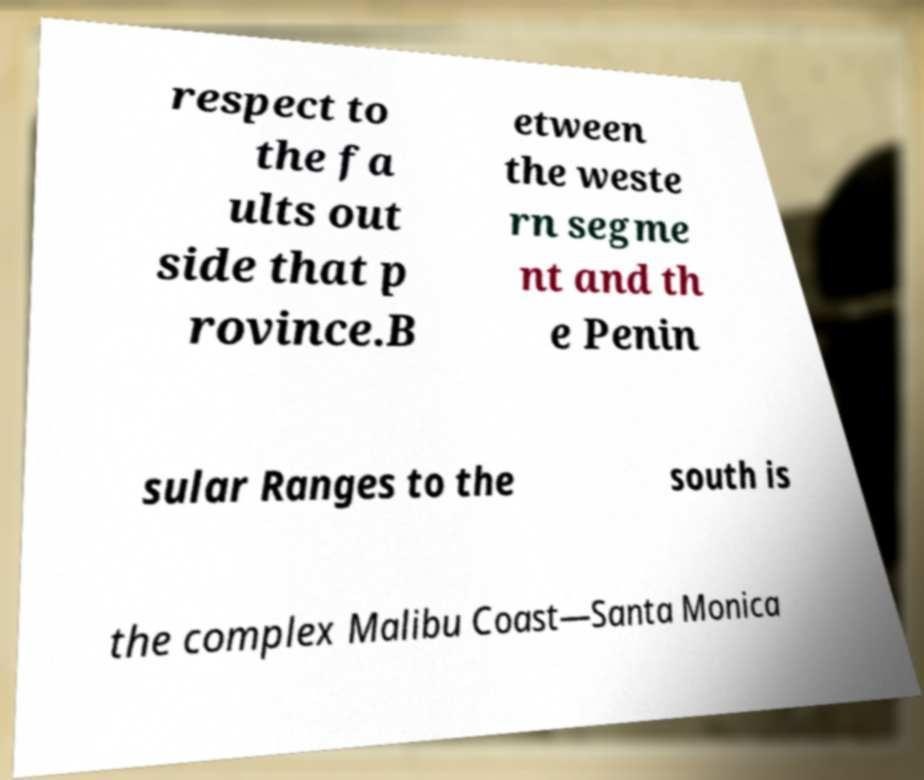Could you assist in decoding the text presented in this image and type it out clearly? respect to the fa ults out side that p rovince.B etween the weste rn segme nt and th e Penin sular Ranges to the south is the complex Malibu Coast—Santa Monica 